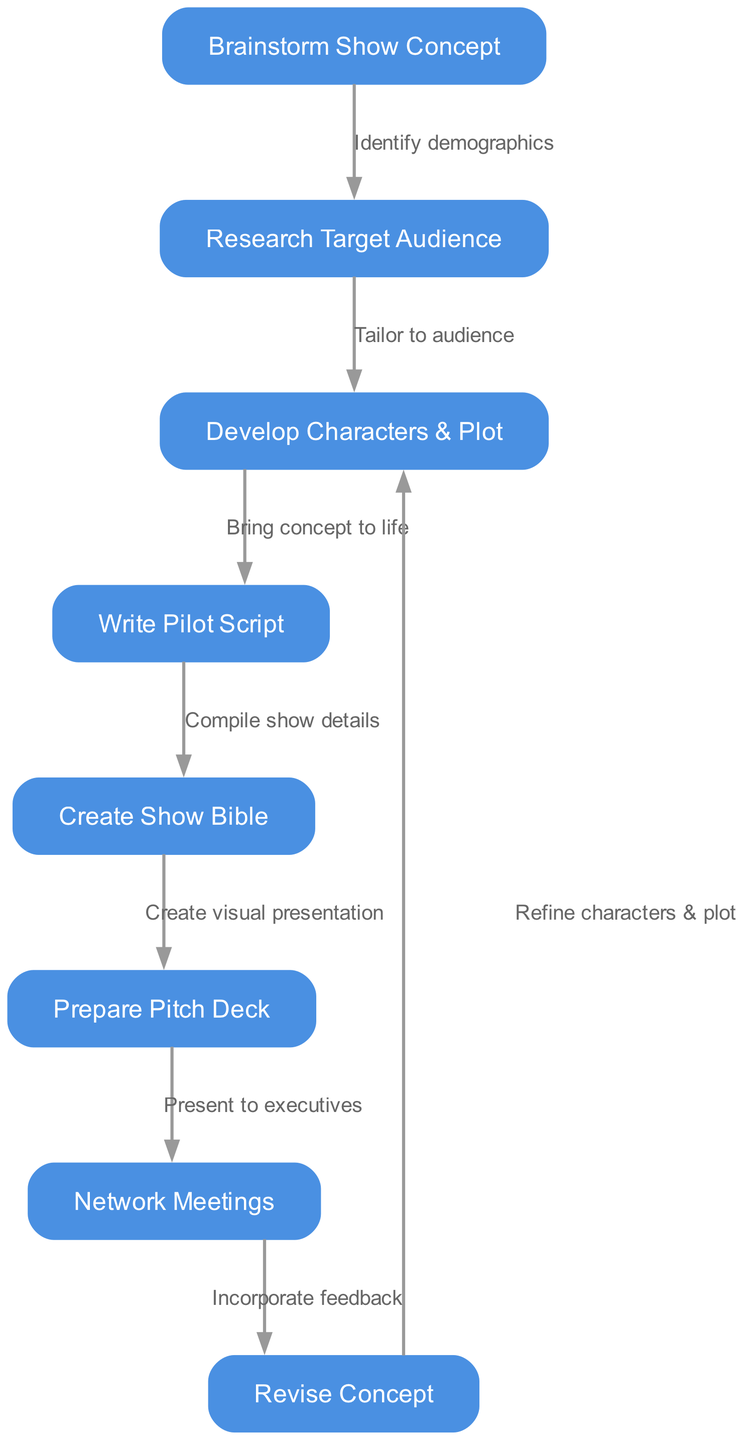What is the first step in the process? The first node in the diagram is labeled "Brainstorm Show Concept," which indicates that brainstorming the show concept is the initial step in developing a TV show.
Answer: Brainstorm Show Concept How many nodes are in the flowchart? Counting the nodes listed in the data, there are a total of eight distinct steps involved in the process, which are represented as nodes in the flowchart.
Answer: 8 What action occurs after writing the pilot script? The flowchart indicates that after "Write Pilot Script," the next step is "Create Show Bible," which compiles the show's details and serves as a comprehensive guide.
Answer: Create Show Bible What is the relationship between researching the target audience and developing characters? The flowchart shows that after "Research Target Audience," it leads to "Develop Characters & Plot," meaning understanding the target audience informs the development of the show's characters and plot.
Answer: Tailor to audience What happens after network meetings? The diagram shows that following "Network Meetings," you should "Incorporate feedback," indicating that after pitching the concept, feedback from executives is integrated into the show development.
Answer: Incorporate feedback Which step involves creating a visual presentation? The node "Prepare Pitch Deck" specifically indicates the action of creating a visual presentation that summarizes the show concept for potential stakeholders.
Answer: Prepare Pitch Deck What is the final action listed in the diagram? After revising the concept in "Revise Concept," the flowchart loops back to "Develop Characters & Plot," indicating a continuous refinement process, but the final action mentioned is "Revise Concept."
Answer: Revise Concept What process connects pilot script writing to creating a show bible? The flowchart clearly illustrates that “Write Pilot Script” leads directly to “Create Show Bible,” signifying that compiling the show details follows after writing the pilot script.
Answer: Compile show details 